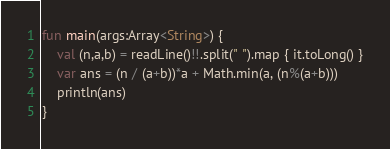<code> <loc_0><loc_0><loc_500><loc_500><_Kotlin_>fun main(args:Array<String>) {
    val (n,a,b) = readLine()!!.split(" ").map { it.toLong() }
    var ans = (n / (a+b))*a + Math.min(a, (n%(a+b)))
    println(ans)
}</code> 